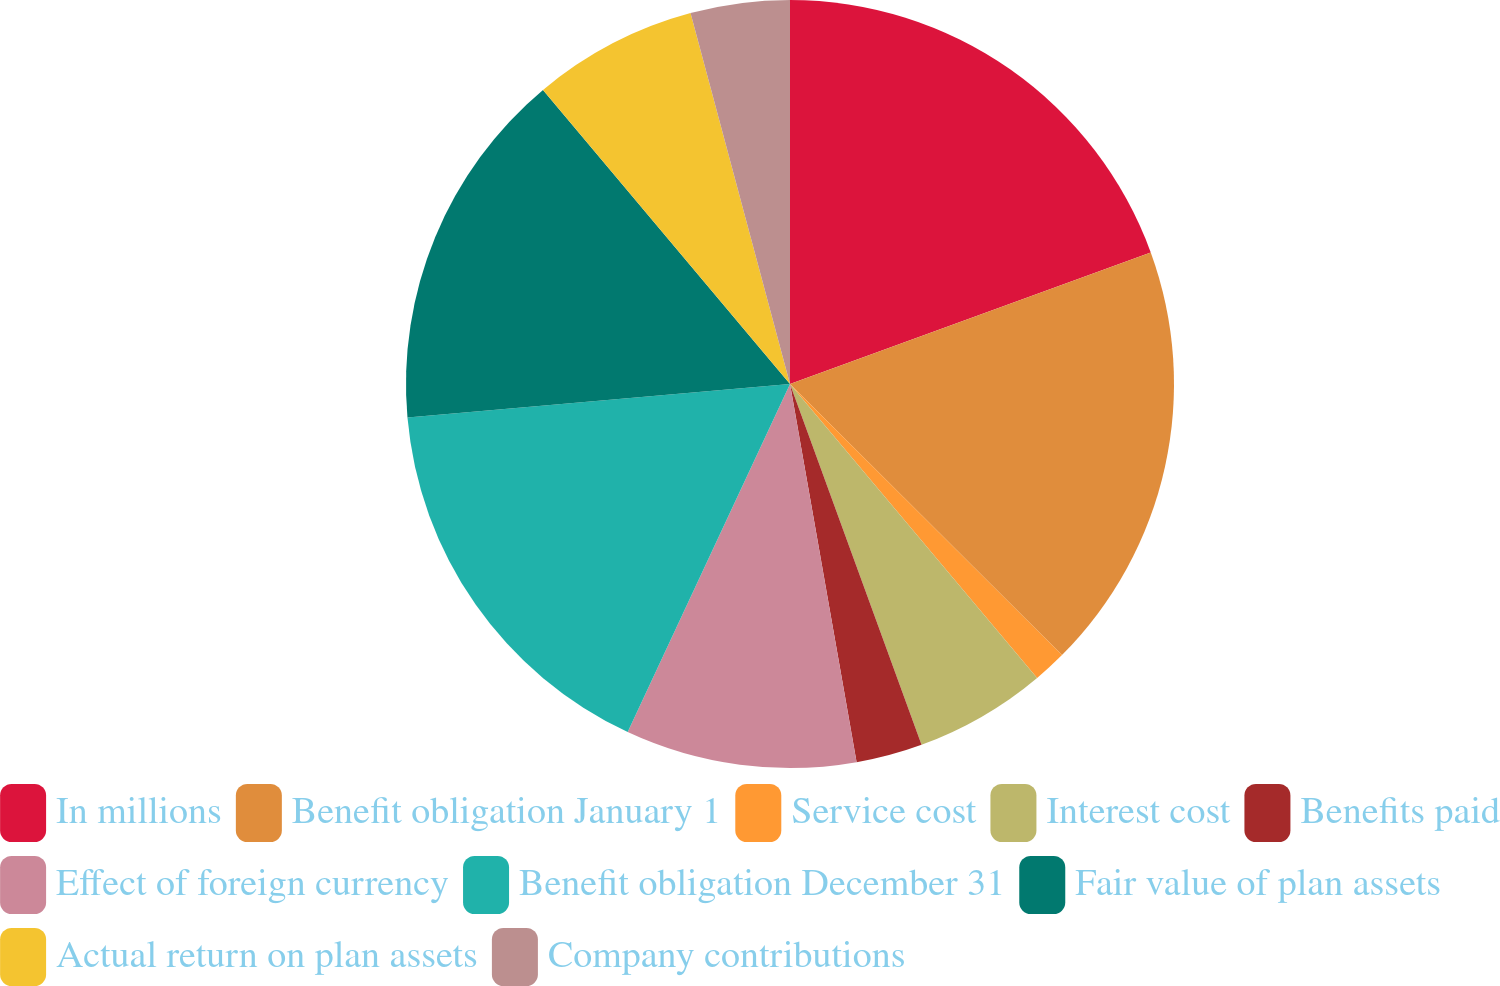Convert chart to OTSL. <chart><loc_0><loc_0><loc_500><loc_500><pie_chart><fcel>In millions<fcel>Benefit obligation January 1<fcel>Service cost<fcel>Interest cost<fcel>Benefits paid<fcel>Effect of foreign currency<fcel>Benefit obligation December 31<fcel>Fair value of plan assets<fcel>Actual return on plan assets<fcel>Company contributions<nl><fcel>19.43%<fcel>18.04%<fcel>1.4%<fcel>5.56%<fcel>2.79%<fcel>9.72%<fcel>16.66%<fcel>15.27%<fcel>6.95%<fcel>4.17%<nl></chart> 